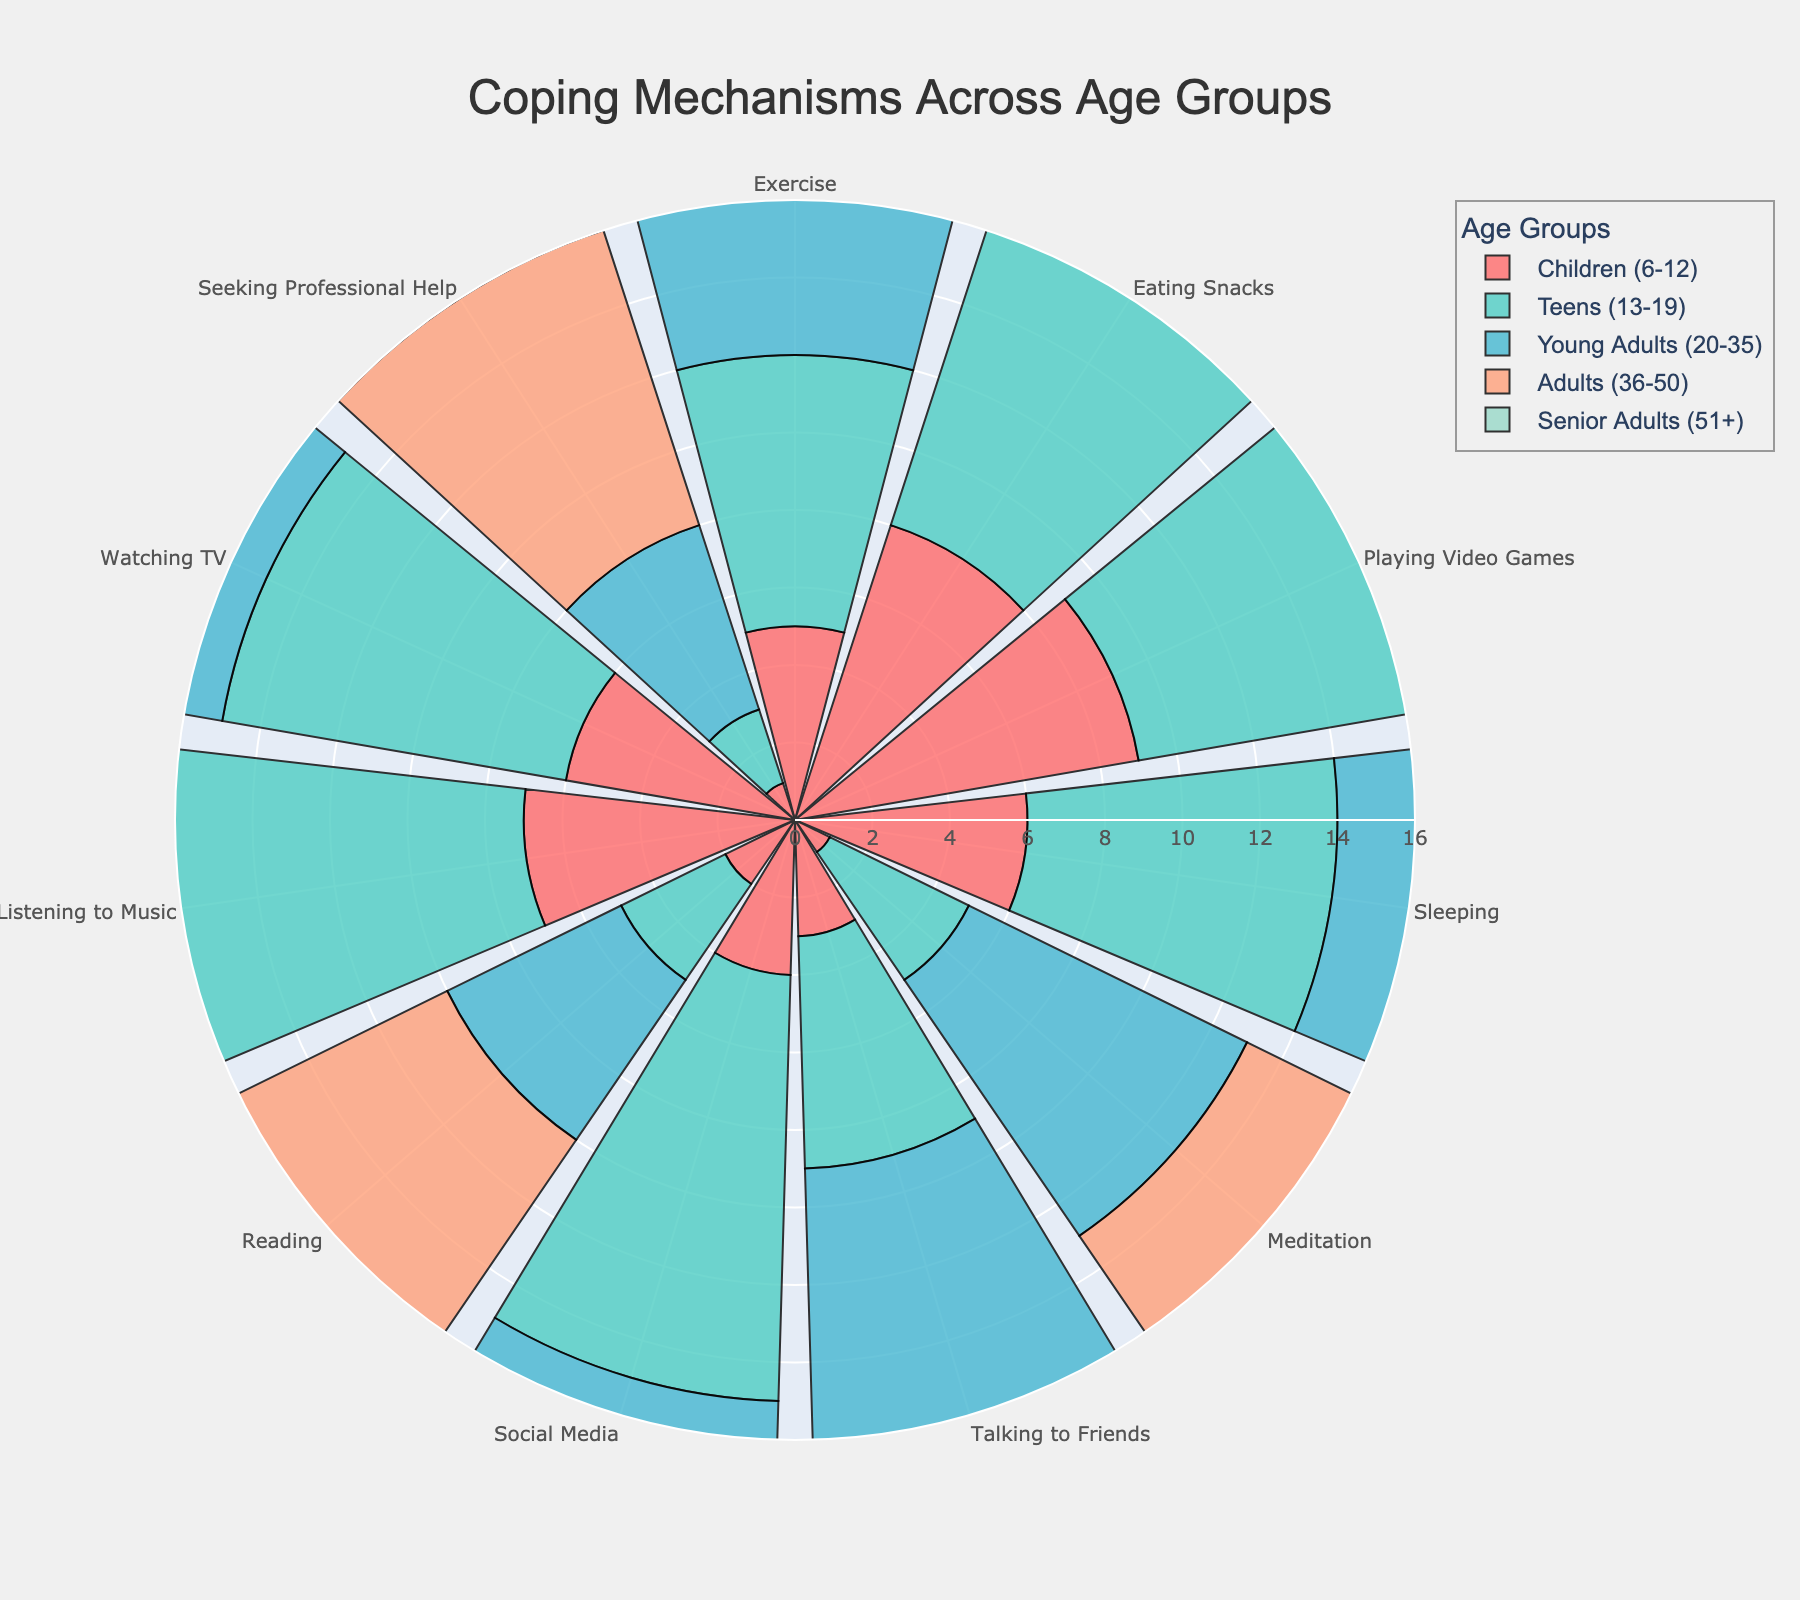What is the title of the rose chart? The title is usually located at the top of the chart and is visually distinct. In this case, it reads "Coping Mechanisms Across Age Groups."
Answer: Coping Mechanisms Across Age Groups Which age group has the highest frequency of using meditation as a coping mechanism? By examining the radial lengths for each age group under the "Meditation" category, Senior Adults (51+) have the longest bar, indicating the highest frequency.
Answer: Senior Adults (51+) How does the frequency of reading compare between Young Adults (20-35) and Adults (36-50)? We need to look at the radial lengths for the "Reading" category for both age groups. Young Adults have a frequency of 5, while Adults have a frequency of 7, showing that Adults (36-50) read more than Young Adults (20-35).
Answer: Adults (36-50) read more Which coping mechanism is used the least by Teens (13-19)? By scanning through the radial lengths for all coping mechanisms under Teens, "Seeking Professional Help" has the shortest length, indicating the least usage.
Answer: Seeking Professional Help What is the difference in the frequency of playing video games between Teens (13-19) and Senior Adults (51+)? We need to find the lengths for the "Playing Video Games" category for both age groups. Teens have a frequency of 12, while Senior Adults have a frequency of 1. The difference is 12 - 1 = 11.
Answer: 11 Which age group shows the highest diversity in coping mechanisms, i.e., has the most varied radial lengths? By visually assessing the spread and range of radial lengths across all coping mechanisms, Teens (13-19) display a wide range from 2 to 13, indicating high diversity in their coping strategies.
Answer: Teens (13-19) What is the total frequency of exercising for all age groups combined? Summing the frequencies given for "Exercise" across all age groups: 5 (Children) + 7 (Teens) + 10 (Young Adults) + 9 (Adults) + 6 (Senior Adults) = 37.
Answer: 37 Which age group listens to music the most, and what is the respective frequency? Checking the radial lengths for the "Listening to Music" category, Teens (13-19) have the longest bar at a frequency of 13.
Answer: Teens (13-19), 13 How does the usage of social media change with increasing age? We need to look at the radial lengths for "Social Media" across age groups and observe the trend. The frequencies are: Children (4), Teens (11), Young Adults (14), Adults (6), Senior Adults (2). Social media usage decreases after peaking among Young Adults.
Answer: Decreases after peaking among Young Adults What is the average frequency of seeking professional help across all age groups? Add the frequencies for "Seeking Professional Help" and then divide by the number of age groups: (1 + 2 + 5 + 8 + 11) / 5 = 27 / 5 = 5.4.
Answer: 5.4 